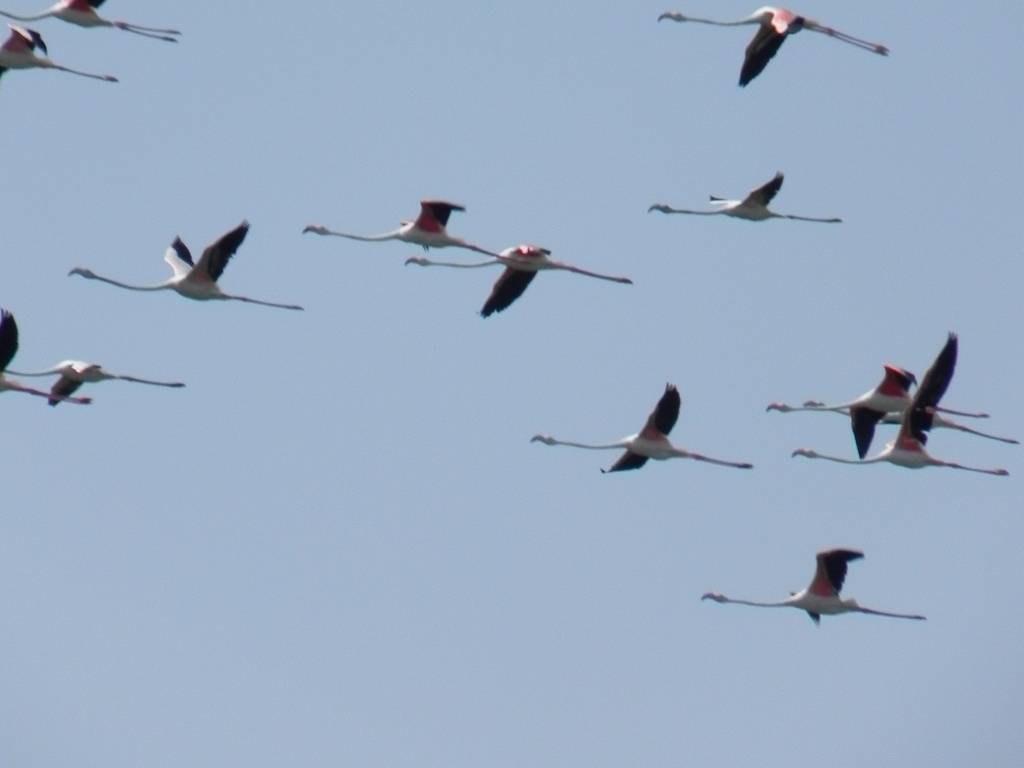How would you describe the colors in the image? The image features a flock of flamingos in flight against a clear blue sky. The flamingos have a striking palette that includes white bodies, black flight feathers, and bold splashes of pink on their wings and tails, which become more vivid when they spread their wings during flight. 